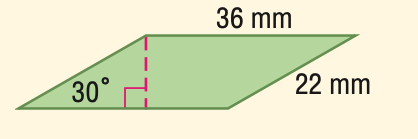Question: Find the area of the parallelogram.
Choices:
A. 396
B. 560.0
C. 685.9
D. 792
Answer with the letter. Answer: A Question: Find the perimeter of the parallelogram.
Choices:
A. 58
B. 72
C. 88
D. 116
Answer with the letter. Answer: D 